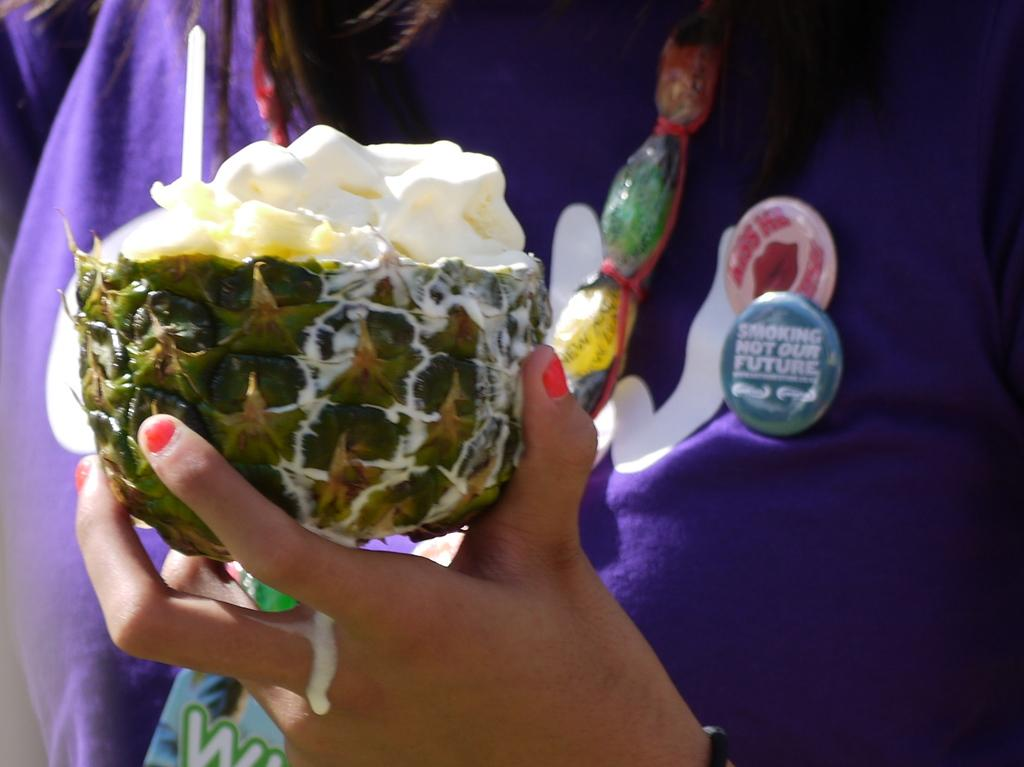What is the main subject of the image? There is a person in the image. What is the person doing in the image? The person is holding food. What is the person wearing in the image? The person is wearing a purple and white color dress. What design elements are present on the dress? There are batches on the dress. What type of prose is the person reading in the image? There is no indication in the image that the person is reading any prose. 